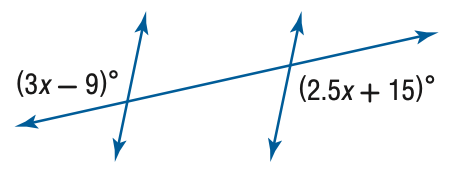Answer the mathemtical geometry problem and directly provide the correct option letter.
Question: Find x.
Choices: A: 6 B: 12 C: 24 D: 48 D 